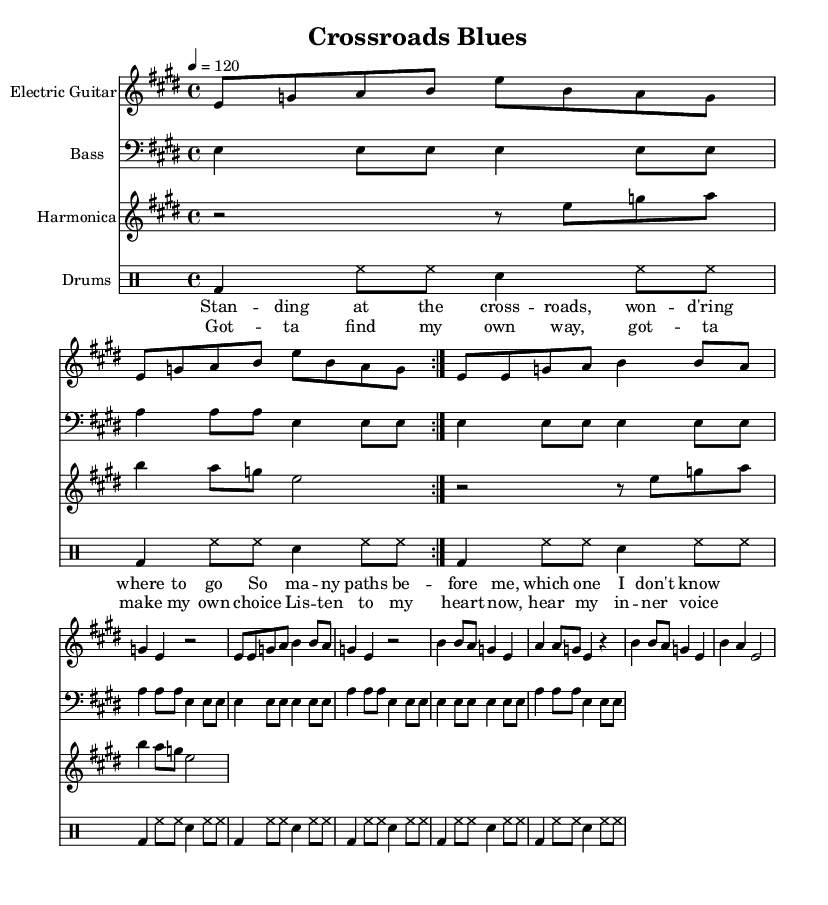What is the key signature of this music? The key signature is E major, which has four sharps (F#, C#, G#, D#). It is indicated at the beginning of the staff right after the clef symbol.
Answer: E major What is the time signature of this music? The time signature is 4/4, which is indicated at the beginning of the staff. It means there are four beats in a measure and the quarter note gets the beat.
Answer: 4/4 What is the tempo marking of this piece? The tempo marking is 120, and it is indicated in beats per minute (bpm). It instructs the musician to play at a moderate tempo of two beats per second.
Answer: 120 How many times is the electric guitar section repeated? The electric guitar section is repeated two times, as indicated by the "volta" instruction in the score. This means to play that section twice before moving to the next part.
Answer: 2 What are the lyrics of the chorus? The lyrics of the chorus are “Gotta find my own way, gotta make my own choice, listen to my heart now, hear my inner voice.” This section encapsulates the song's theme of self-discovery.
Answer: Gotta find my own way, gotta make my own choice, listen to my heart now, hear my inner voice What instruments are included in this arrangement? The arrangement includes electric guitar, bass, harmonica, and drums. Each instrument is assigned to its own staff in the score.
Answer: Electric guitar, bass, harmonica, drums What style of music does this piece represent? This piece represents the Electric Blues style, characterized by its use of electric instruments, a steady rhythm, and a focus on emotional expression.
Answer: Electric Blues 